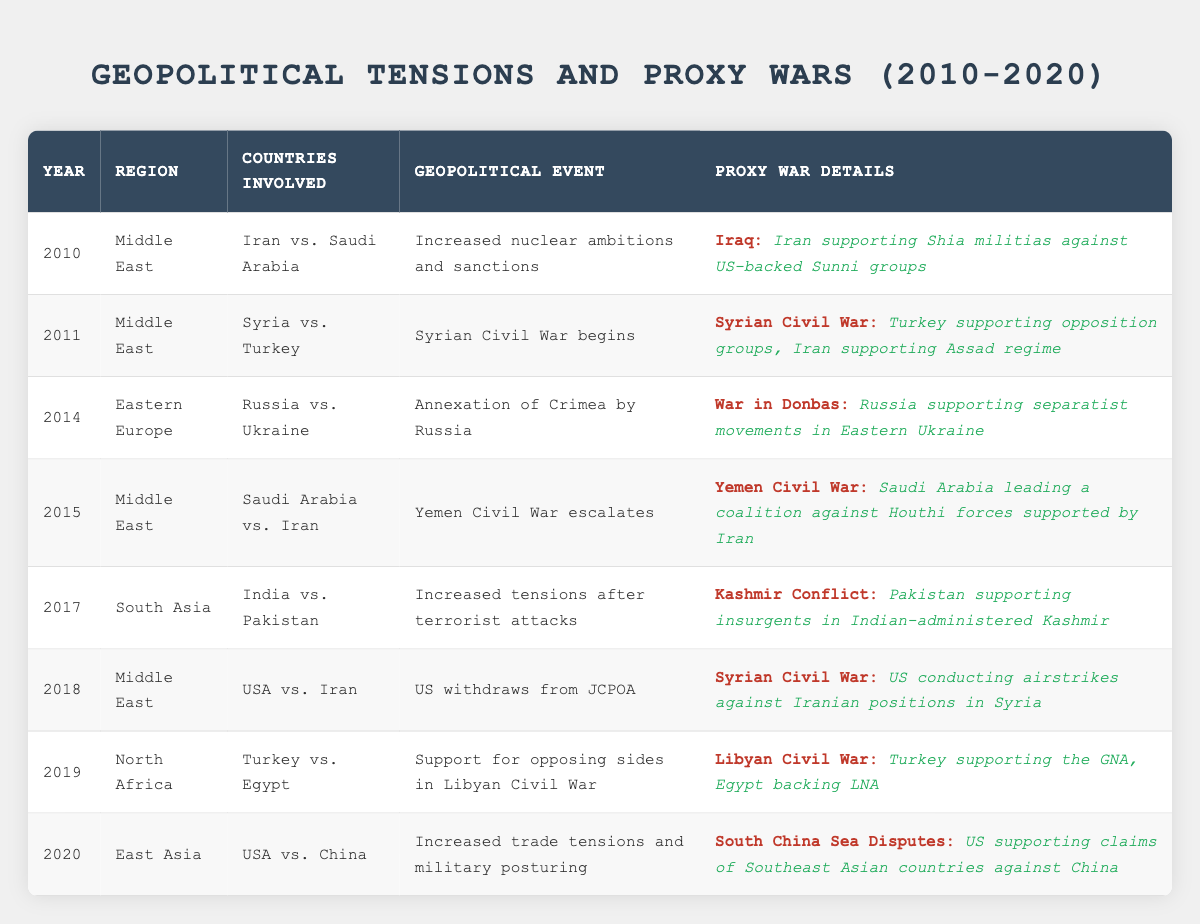What geopolitical event occurred in 2015? The table indicates that in 2015, the geopolitical event was the escalation of the Yemen Civil War. This can be directly found in the entry for that year.
Answer: Yemen Civil War escalates Which two countries were involved in the proxy war during the Syrian Civil War in 2011? By looking at the 2011 row, we see that Turkey was supporting opposition groups while Iran was supporting the Assad regime, indicating their involvement in the proxy war during the Syrian Civil War for that year.
Answer: Turkey and Iran How many different proxy war conflicts were mentioned across the years in the table? The table lists several specific conflicts: Iraq (2010), Syrian Civil War (2011), War in Donbas (2014), Yemen Civil War (2015), Kashmir Conflict (2017), Libyan Civil War (2019), and South China Sea Disputes (2020). Counting these gives a total of 7 unique conflicts.
Answer: 7 Was there any proxy war conflict involving the USA in 2018? Referring to the row for the year 2018, it shows that the USA was involved in the proxy war conflict in the Syrian Civil War, conducting airstrikes against Iranian positions in Syria. Thus, the statement is true.
Answer: Yes In which region did the most proxy wars occur according to the table? Analyzing the table entries reveals that the Middle East has proxy wars listed for the years 2010, 2011, 2015, and 2018. Counting these establishes that the Middle East had the most entries, totaling four proxy wars, while other regions have fewer.
Answer: Middle East How many proxy wars occurred after the annexation of Crimea by Russia in 2014? After 2014, the records show proxy wars for the years 2015 (Yemen Civil War), 2017 (Kashmir Conflict), 2018 (Syrian Civil War), 2019 (Libyan Civil War), and 2020 (South China Sea Disputes). Counting these entries results in five proxy wars following the event.
Answer: 5 What type of military support was provided by Russia in 2014? In the 2014 entry related to the War in Donbas, it specifically states that Russia supported separatist movements in Eastern Ukraine, indicating the type of military support.
Answer: Military Support Which two countries were in conflict over the Libyan Civil War in 2019? The table clearly shows that Turkey supported the Government of National Accord (GNA) while Egypt backed the Libyan National Army (LNA) during the Libyan Civil War in 2019, thus identifying the two countries in conflict.
Answer: Turkey and Egypt 